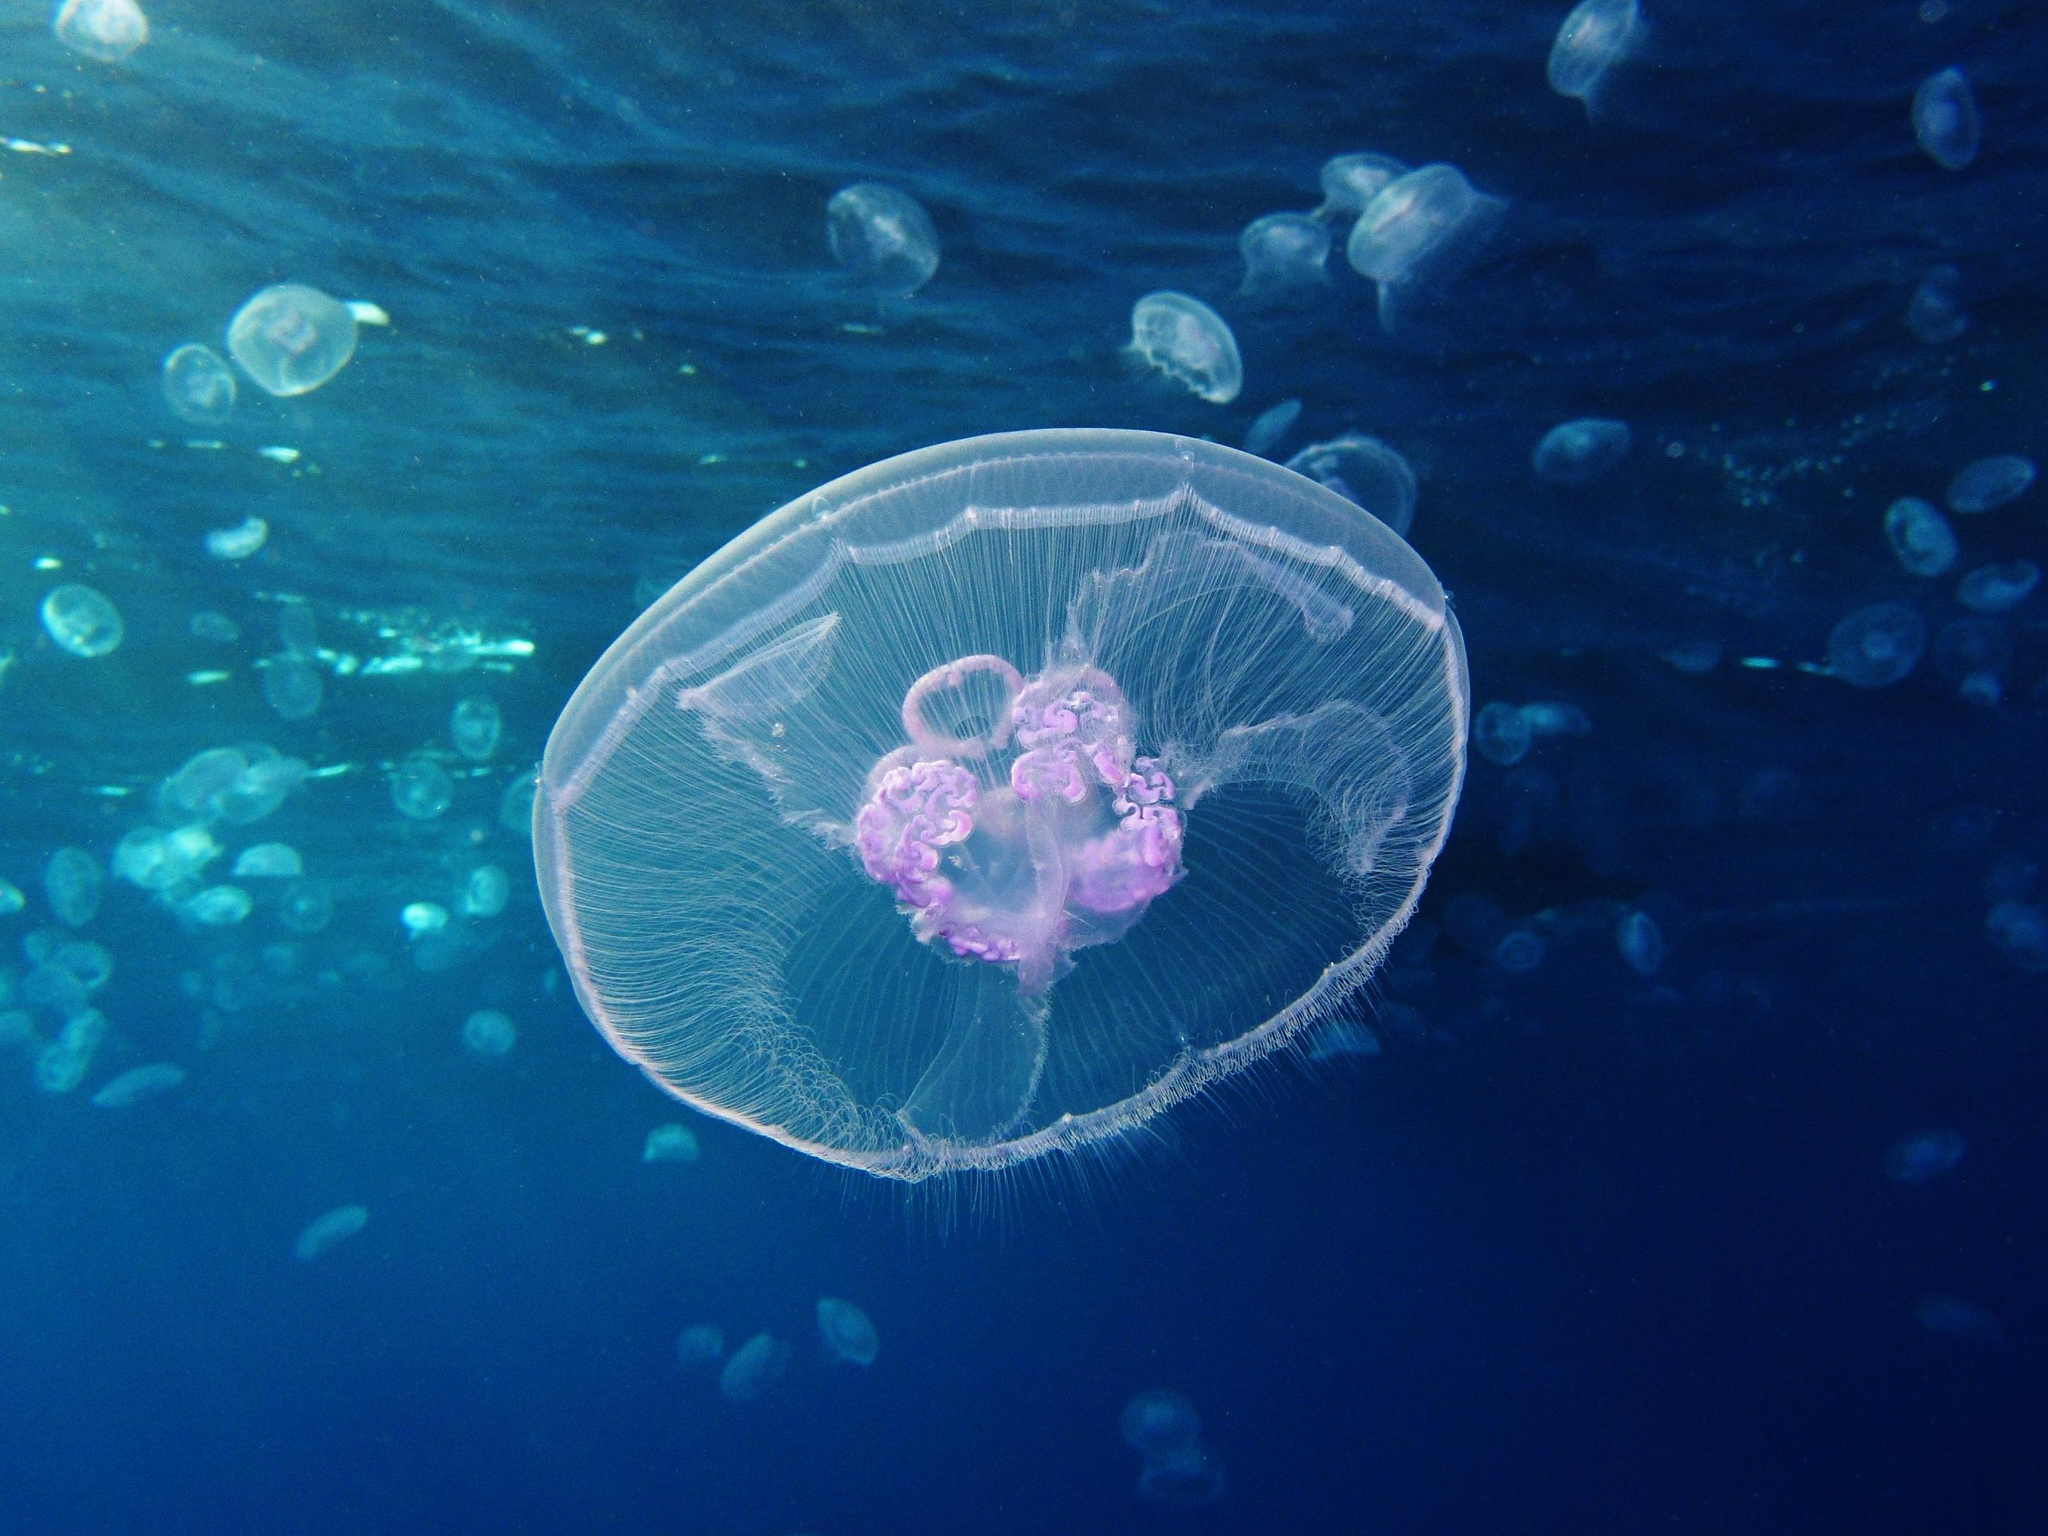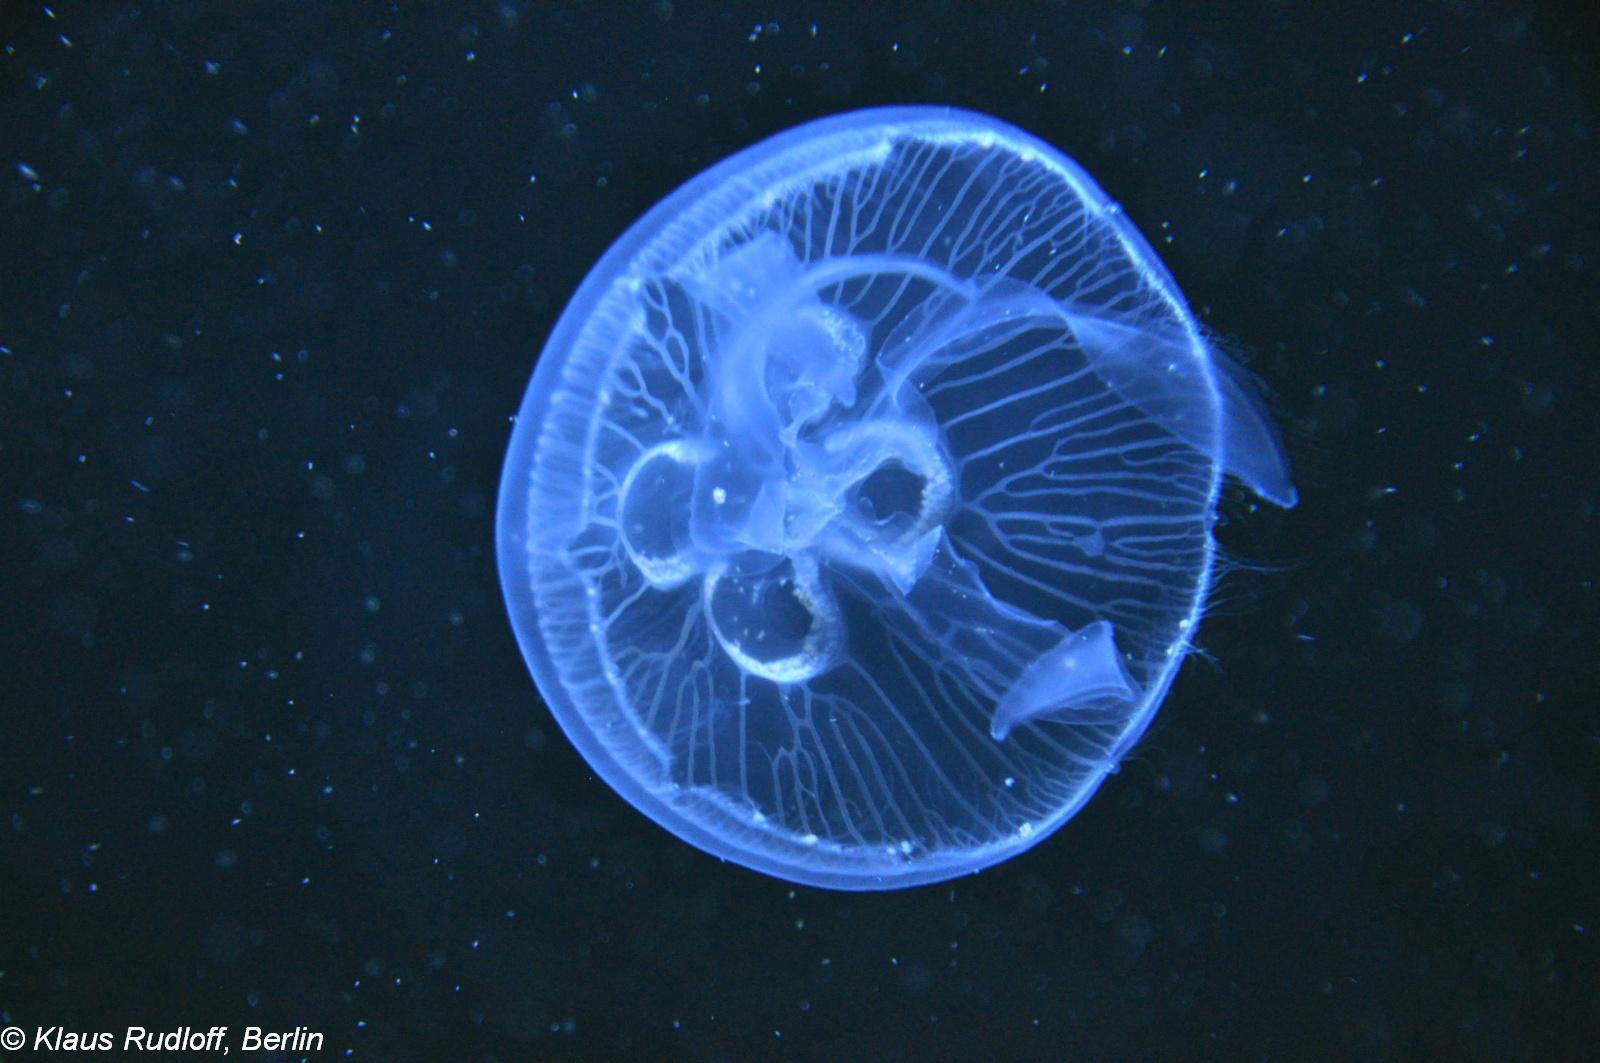The first image is the image on the left, the second image is the image on the right. Evaluate the accuracy of this statement regarding the images: "There are at least 20 sea creatures in one of the images.". Is it true? Answer yes or no. Yes. 